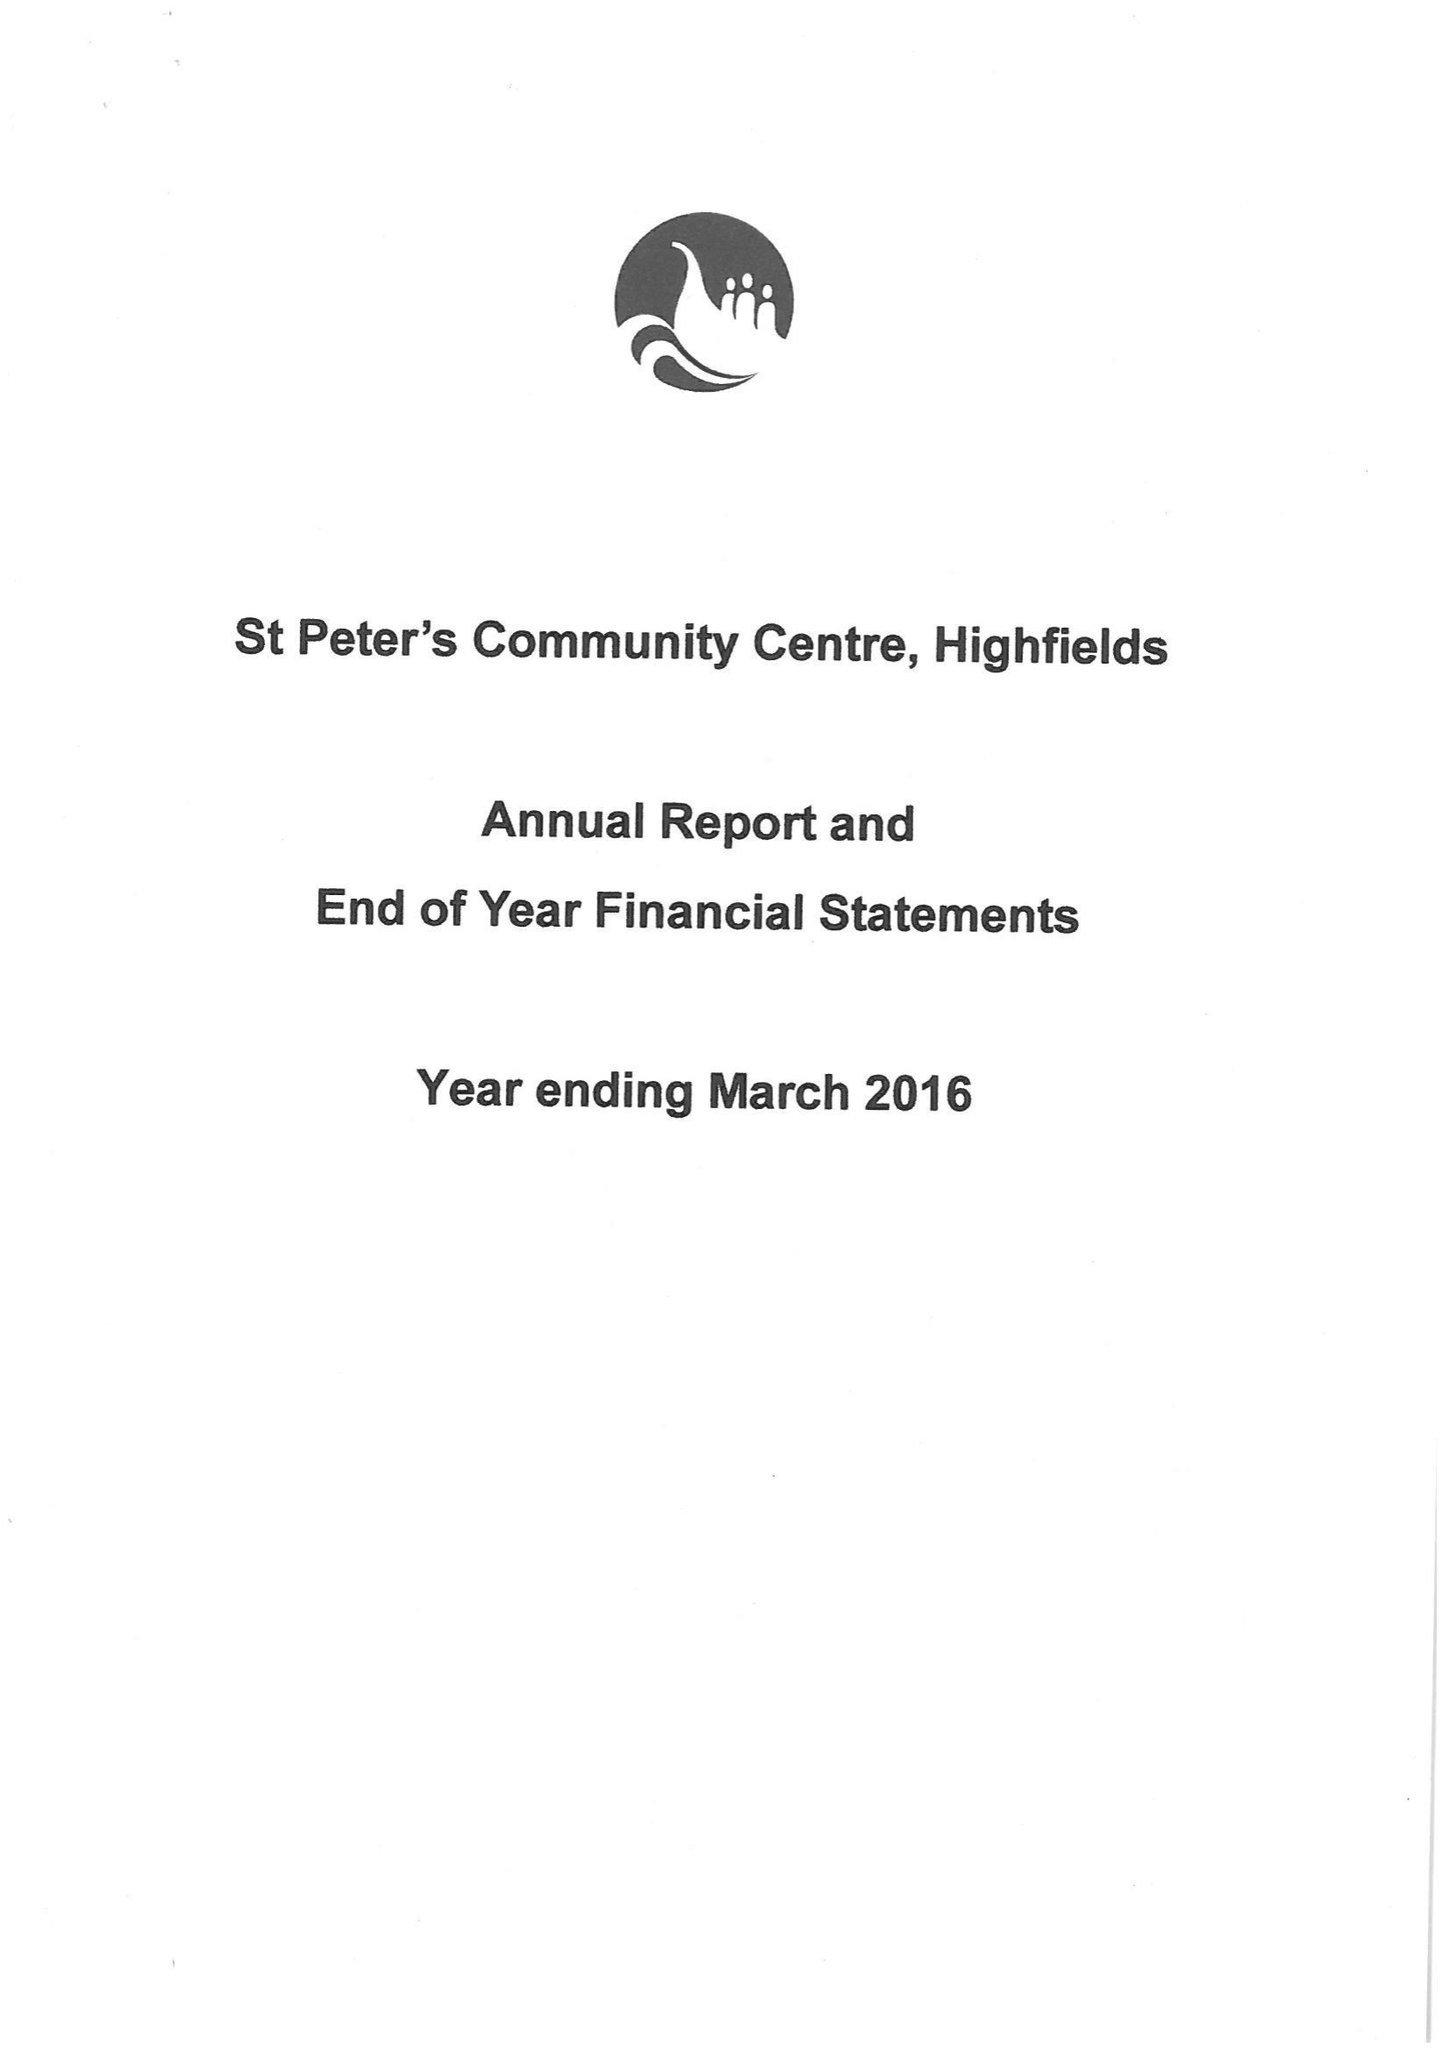What is the value for the report_date?
Answer the question using a single word or phrase. 2016-03-31 